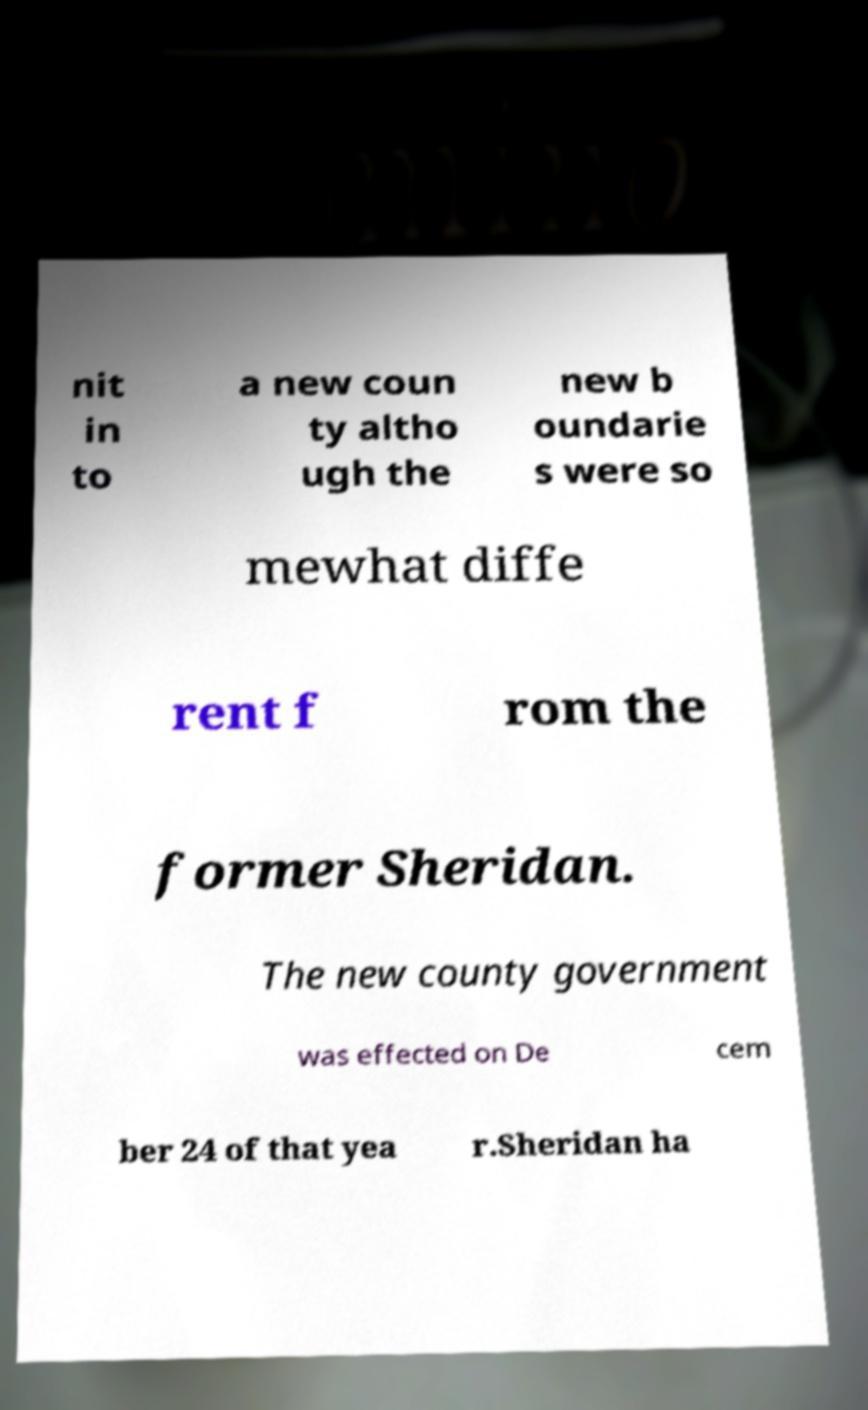There's text embedded in this image that I need extracted. Can you transcribe it verbatim? nit in to a new coun ty altho ugh the new b oundarie s were so mewhat diffe rent f rom the former Sheridan. The new county government was effected on De cem ber 24 of that yea r.Sheridan ha 